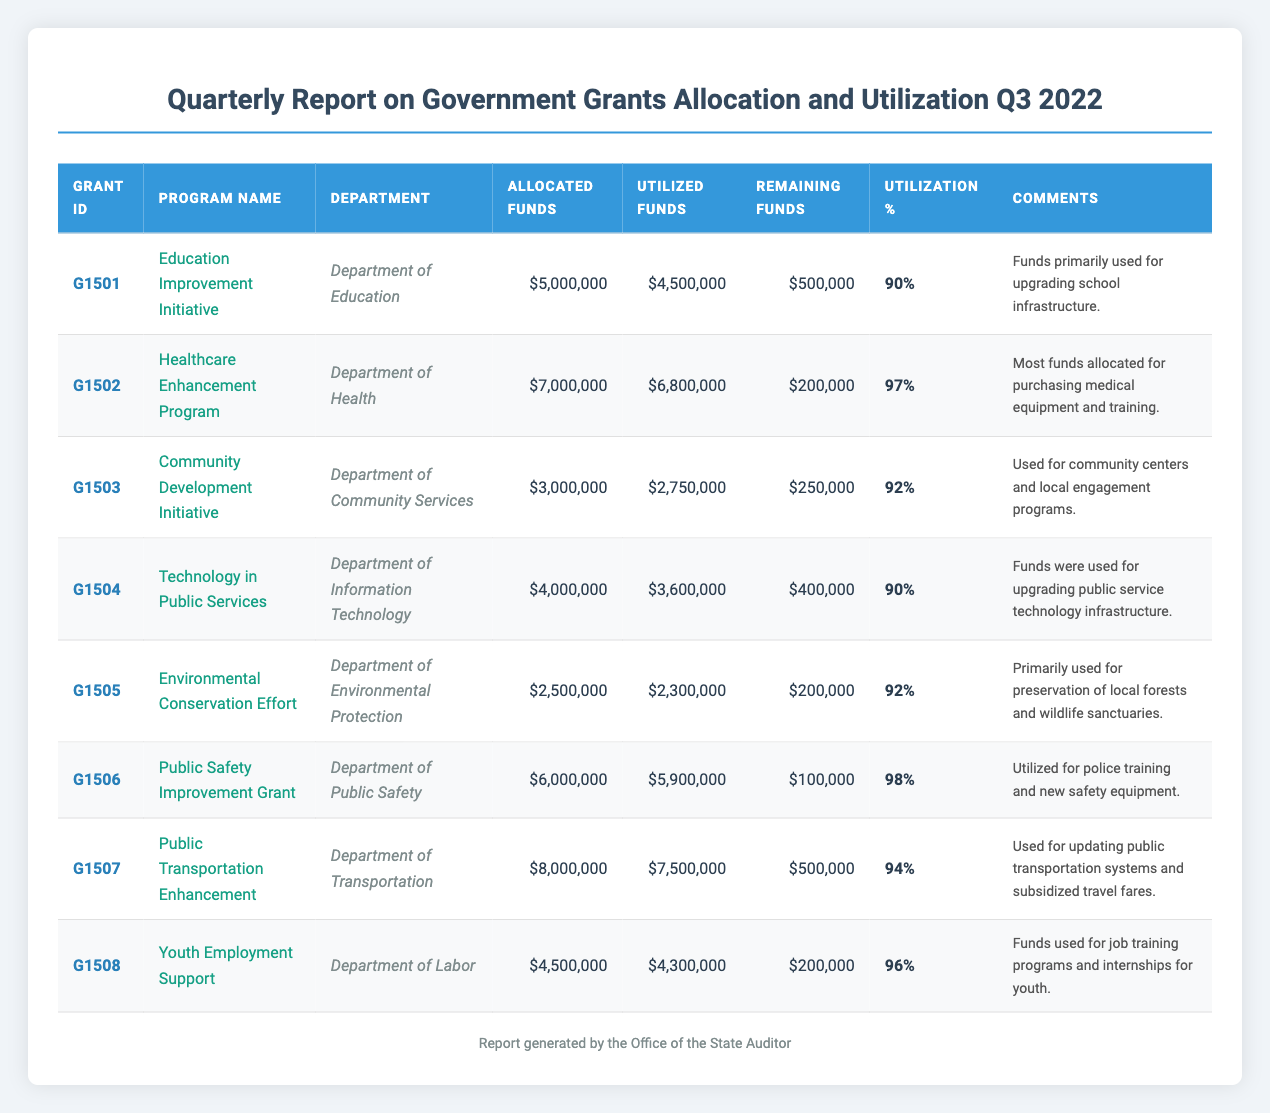What is the total amount allocated for all grants? To find the total allocated funds, sum the allocated funds of all grants: 5000000 + 7000000 + 3000000 + 4000000 + 2500000 + 6000000 + 8000000 + 4500000 = 30500000.
Answer: 30500000 Which program has the highest utilization percentage? Looking at the utilization percentages, the Healthcare Enhancement Program has the highest utilization percentage at 97%.
Answer: Healthcare Enhancement Program How much remaining funds does the Public Safety Improvement Grant have? Referencing the table, the Public Safety Improvement Grant has remaining funds of 100000.
Answer: 100000 Is the total utilized funds greater than the total allocated funds for all grants? The total utilized funds is 4500000 + 6800000 + 2750000 + 3600000 + 2300000 + 5900000 + 7500000 + 4300000 = 28600000, which is less than the total allocated funds of 30500000. Therefore, the statement is false.
Answer: No What is the average utilization percentage of all programs? To find the average, sum up the utilization percentages: 90 + 97 + 92 + 90 + 92 + 98 + 94 + 96 = 739, and then divide by the number of programs (8): 739 / 8 = 92.375. Rounding it gives an average of 92.4%.
Answer: 92.4% How much more funding was utilized in the Healthcare Enhancement Program compared to the Youth Employment Support program? The Healthcare Enhancement Program utilized 6800000, while the Youth Employment Support program utilized 4300000. The difference is calculated as 6800000 - 4300000 = 2500000.
Answer: 2500000 How many grants were utilized at 90% or above? Checking the utilization percentages, the programs with 90% or above are: Education Improvement Initiative (90%), Healthcare Enhancement Program (97%), Community Development Initiative (92%), Technology in Public Services (90%), Environmental Conservation Effort (92%), Public Safety Improvement Grant (98%), Public Transportation Enhancement (94%), and Youth Employment Support (96%). Thus, there are 8 grants.
Answer: 8 Did the Department of Transportation utilize all of their allocated funds? The Department of Transportation allocated 8000000 and utilized 7500000, thus they did not utilize all the funds as there are remaining funds (500000). Therefore, the answer is no.
Answer: No 